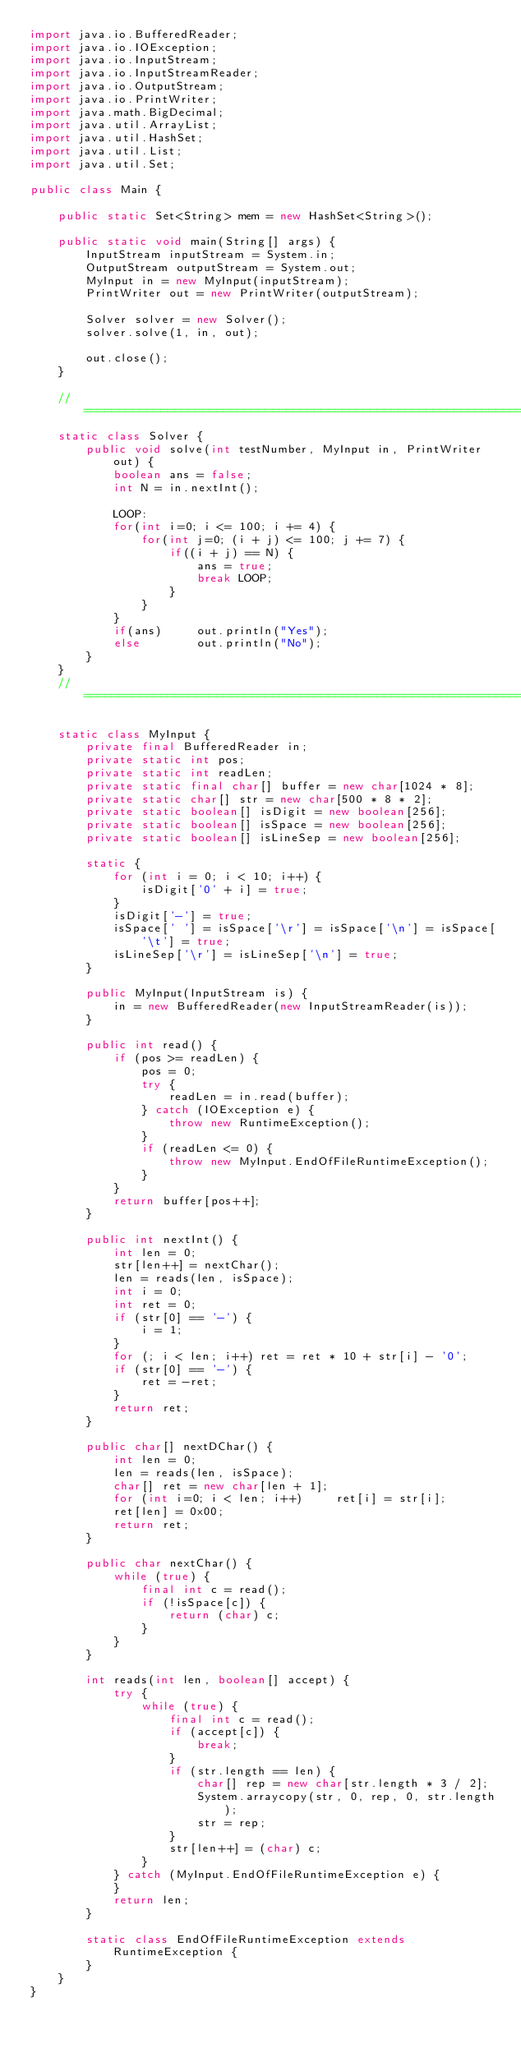<code> <loc_0><loc_0><loc_500><loc_500><_Java_>import java.io.BufferedReader;
import java.io.IOException;
import java.io.InputStream;
import java.io.InputStreamReader;
import java.io.OutputStream;
import java.io.PrintWriter;
import java.math.BigDecimal;
import java.util.ArrayList;
import java.util.HashSet;
import java.util.List;
import java.util.Set;

public class Main {
	
	public static Set<String> mem = new HashSet<String>();
	
    public static void main(String[] args) {
        InputStream inputStream = System.in;
        OutputStream outputStream = System.out;
        MyInput in = new MyInput(inputStream);
        PrintWriter out = new PrintWriter(outputStream);
        
        Solver solver = new Solver();
        solver.solve(1, in, out);
        
        out.close();
    }
    
    // ======================================================================
    static class Solver {
        public void solve(int testNumber, MyInput in, PrintWriter out) {
        	boolean ans = false;
            int N = in.nextInt();

            LOOP:
            for(int i=0; i <= 100; i += 4) {
            	for(int j=0; (i + j) <= 100; j += 7) {
            		if((i + j) == N) {
            			ans = true;
            			break LOOP;
            		}
            	}
            }
            if(ans)		out.println("Yes");
            else		out.println("No");
        }
    }
    // ======================================================================
    
    static class MyInput {
        private final BufferedReader in;
        private static int pos;
        private static int readLen;
        private static final char[] buffer = new char[1024 * 8];
        private static char[] str = new char[500 * 8 * 2];
        private static boolean[] isDigit = new boolean[256];
        private static boolean[] isSpace = new boolean[256];
        private static boolean[] isLineSep = new boolean[256];
 
        static {
            for (int i = 0; i < 10; i++) {
                isDigit['0' + i] = true;
            }
            isDigit['-'] = true;
            isSpace[' '] = isSpace['\r'] = isSpace['\n'] = isSpace['\t'] = true;
            isLineSep['\r'] = isLineSep['\n'] = true;
        }
 
        public MyInput(InputStream is) {
            in = new BufferedReader(new InputStreamReader(is));
        }
 
        public int read() {
            if (pos >= readLen) {
                pos = 0;
                try {
                    readLen = in.read(buffer);
                } catch (IOException e) {
                    throw new RuntimeException();
                }
                if (readLen <= 0) {
                    throw new MyInput.EndOfFileRuntimeException();
                }
            }
            return buffer[pos++];
        }
 
        public int nextInt() {
            int len = 0;
            str[len++] = nextChar();
            len = reads(len, isSpace);
            int i = 0;
            int ret = 0;
            if (str[0] == '-') {
                i = 1;
            }
            for (; i < len; i++) ret = ret * 10 + str[i] - '0';
            if (str[0] == '-') {
                ret = -ret;
            }
            return ret;
        }
 
        public char[] nextDChar() {
            int len = 0;
            len = reads(len, isSpace);
            char[] ret = new char[len + 1];
            for (int i=0; i < len; i++)		ret[i] = str[i];
            ret[len] = 0x00;
            return ret;
        }
 
        public char nextChar() {
            while (true) {
                final int c = read();
                if (!isSpace[c]) {
                    return (char) c;
                }
            }
        }
 
        int reads(int len, boolean[] accept) {
            try {
                while (true) {
                    final int c = read();
                    if (accept[c]) {
                        break;
                    }
                    if (str.length == len) {
                        char[] rep = new char[str.length * 3 / 2];
                        System.arraycopy(str, 0, rep, 0, str.length);
                        str = rep;
                    }
                    str[len++] = (char) c;
                }
            } catch (MyInput.EndOfFileRuntimeException e) {
            }
            return len;
        }
 
        static class EndOfFileRuntimeException extends RuntimeException {
        }
    }
}
</code> 